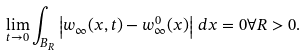Convert formula to latex. <formula><loc_0><loc_0><loc_500><loc_500>\lim _ { t \to 0 } \int _ { B _ { R } } \left | w _ { \infty } ( x , t ) - w _ { \infty } ^ { 0 } ( x ) \right | \, d x = 0 \forall R > 0 .</formula> 